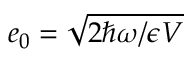Convert formula to latex. <formula><loc_0><loc_0><loc_500><loc_500>e _ { 0 } = \sqrt { 2 \hbar { \omega } / \epsilon V }</formula> 